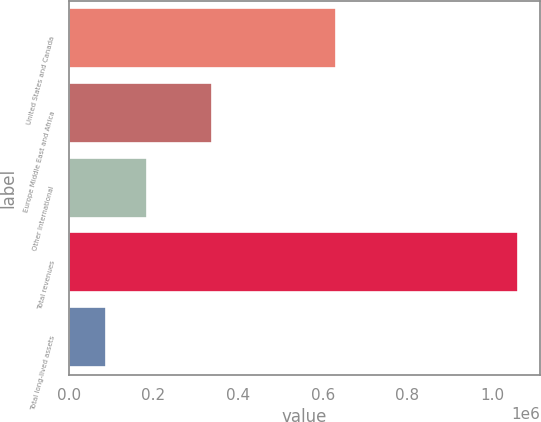Convert chart to OTSL. <chart><loc_0><loc_0><loc_500><loc_500><bar_chart><fcel>United States and Canada<fcel>Europe Middle East and Africa<fcel>Other International<fcel>Total revenues<fcel>Total long-lived assets<nl><fcel>631295<fcel>337722<fcel>185158<fcel>1.06032e+06<fcel>87918<nl></chart> 